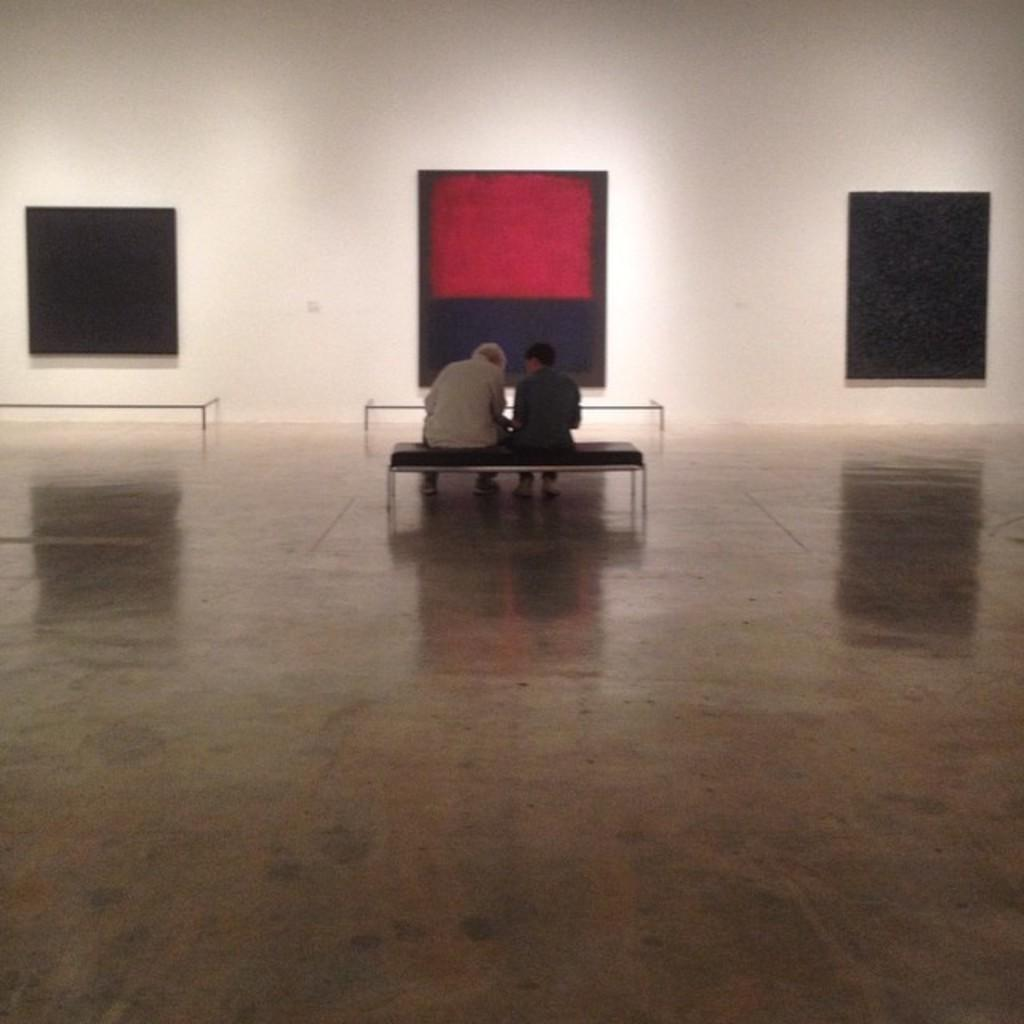How many people are sitting on a bench in the image? There are two persons sitting on a bench in the image. Are there any other benches visible in the image? Yes, there are two other benches in the image. What can be seen in the background of the image? There is a wall and windows visible in the image. What type of fruit is being eaten by the person wearing a mask in the image? There is no fruit or person wearing a mask present in the image. 